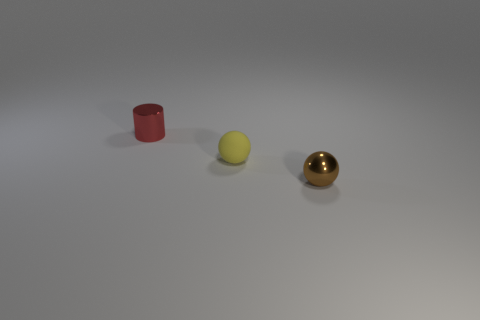Is there any other thing that is made of the same material as the brown object?
Offer a very short reply. Yes. Does the matte thing have the same color as the tiny object behind the rubber sphere?
Provide a short and direct response. No. What shape is the small red metal object?
Provide a short and direct response. Cylinder. There is a brown shiny ball that is on the right side of the tiny yellow object that is behind the metal object on the right side of the tiny red object; how big is it?
Your response must be concise. Small. What number of other things are the same shape as the red shiny object?
Keep it short and to the point. 0. Do the thing that is behind the yellow rubber thing and the shiny thing on the right side of the red metallic cylinder have the same shape?
Your answer should be compact. No. How many spheres are small things or small brown things?
Make the answer very short. 2. There is a small object that is left of the tiny ball that is behind the metallic object in front of the yellow matte thing; what is its material?
Offer a terse response. Metal. What number of other things are there of the same size as the brown object?
Give a very brief answer. 2. Are there more small red things to the right of the yellow sphere than metallic cylinders?
Give a very brief answer. No. 